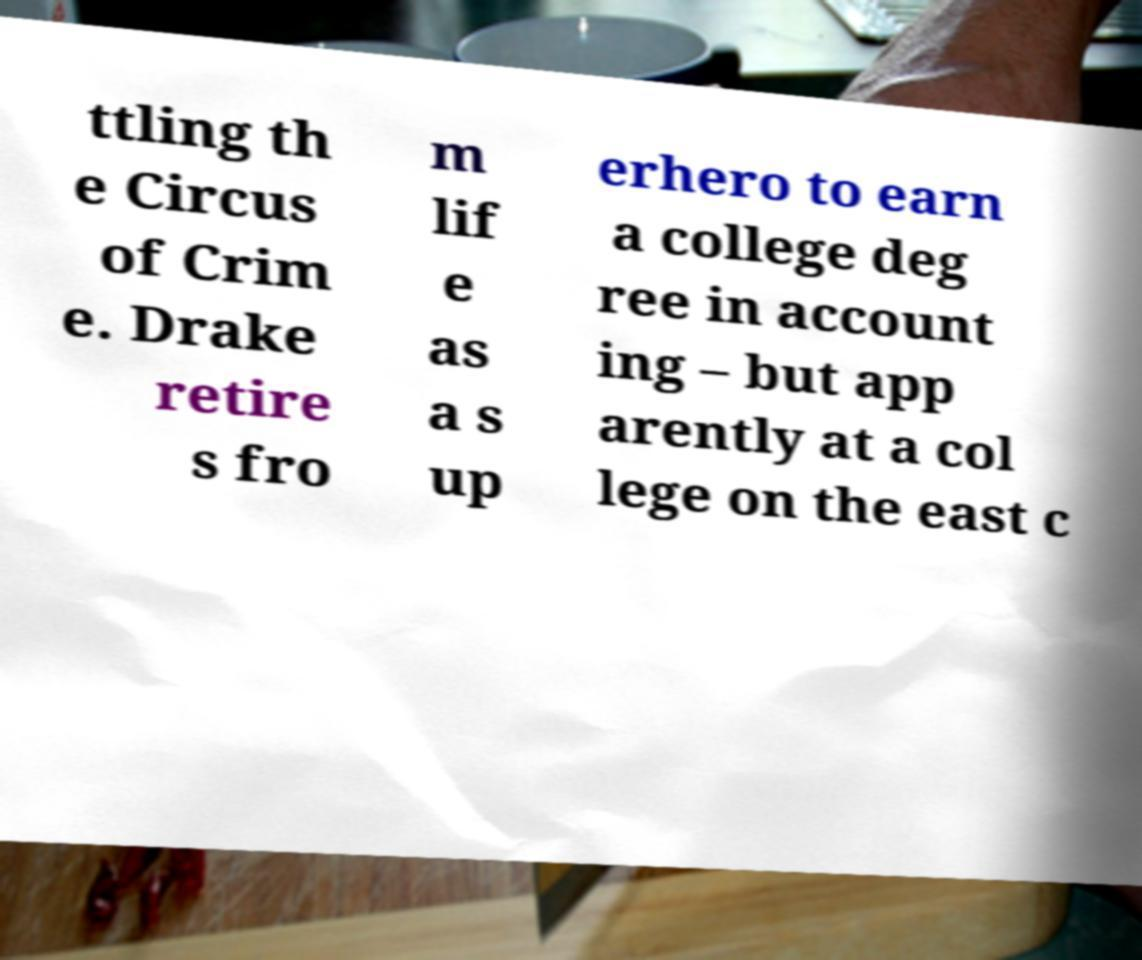Can you read and provide the text displayed in the image?This photo seems to have some interesting text. Can you extract and type it out for me? ttling th e Circus of Crim e. Drake retire s fro m lif e as a s up erhero to earn a college deg ree in account ing – but app arently at a col lege on the east c 